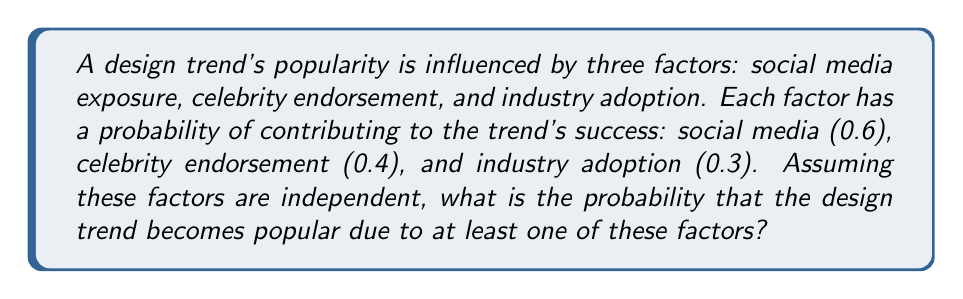Help me with this question. Let's approach this step-by-step using the concept of probability of the union of events:

1) Let's define our events:
   A: Success due to social media exposure
   B: Success due to celebrity endorsement
   C: Success due to industry adoption

2) We're given the following probabilities:
   P(A) = 0.6
   P(B) = 0.4
   P(C) = 0.3

3) We need to find P(A ∪ B ∪ C), which is the probability of at least one of these events occurring.

4) Using the complement rule, we can calculate this as:
   P(A ∪ B ∪ C) = 1 - P(A' ∩ B' ∩ C')

   Where A', B', and C' are the complements of A, B, and C respectively.

5) Since the events are independent, we can multiply the probabilities of the complements:
   P(A' ∩ B' ∩ C') = P(A') × P(B') × P(C')

6) The complements of the probabilities are:
   P(A') = 1 - 0.6 = 0.4
   P(B') = 1 - 0.4 = 0.6
   P(C') = 1 - 0.3 = 0.7

7) Now we can calculate:
   P(A' ∩ B' ∩ C') = 0.4 × 0.6 × 0.7 = 0.168

8) Finally, we can compute the probability of the trend becoming popular:
   P(A ∪ B ∪ C) = 1 - 0.168 = 0.832

Therefore, the probability that the design trend becomes popular due to at least one of these factors is 0.832 or 83.2%.
Answer: 0.832 